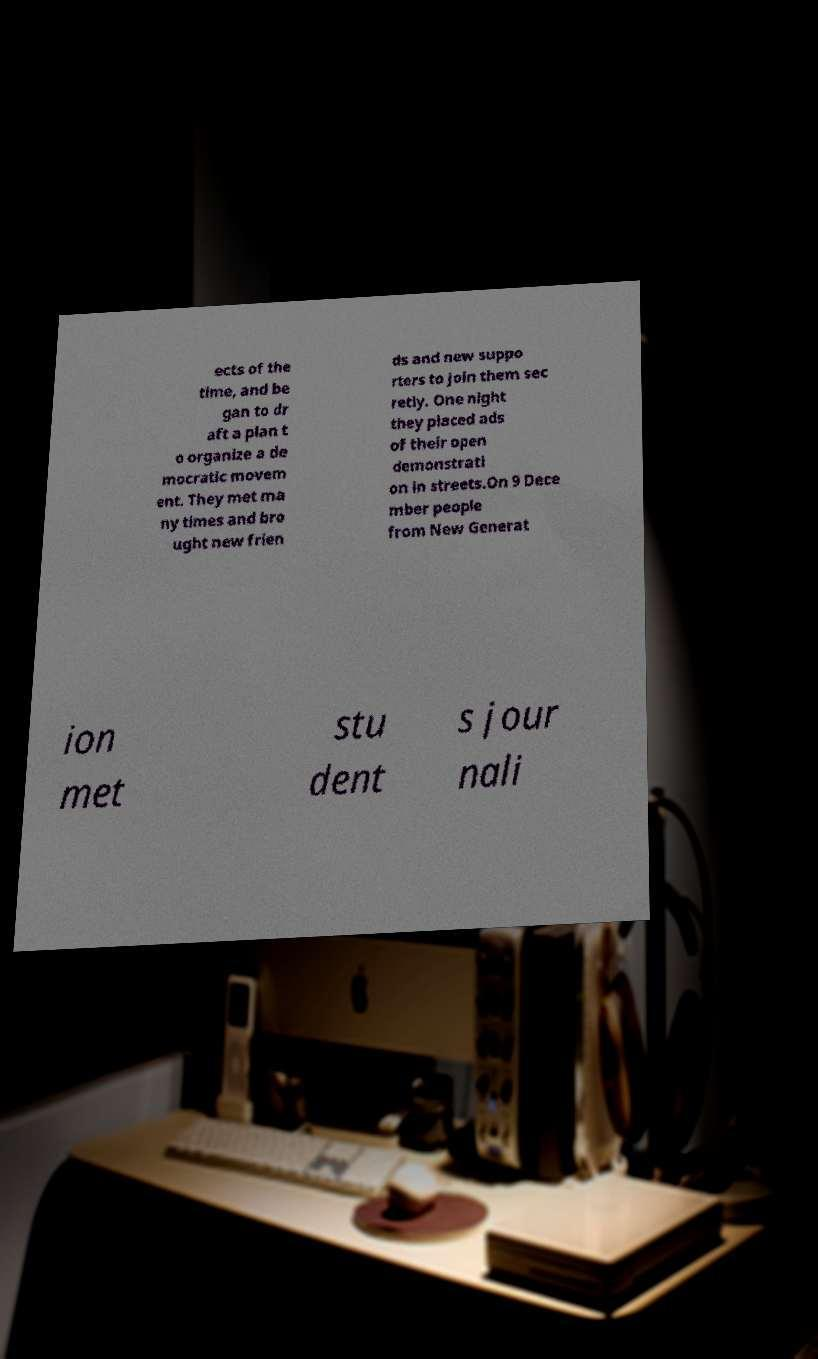Could you assist in decoding the text presented in this image and type it out clearly? ects of the time, and be gan to dr aft a plan t o organize a de mocratic movem ent. They met ma ny times and bro ught new frien ds and new suppo rters to join them sec retly. One night they placed ads of their open demonstrati on in streets.On 9 Dece mber people from New Generat ion met stu dent s jour nali 